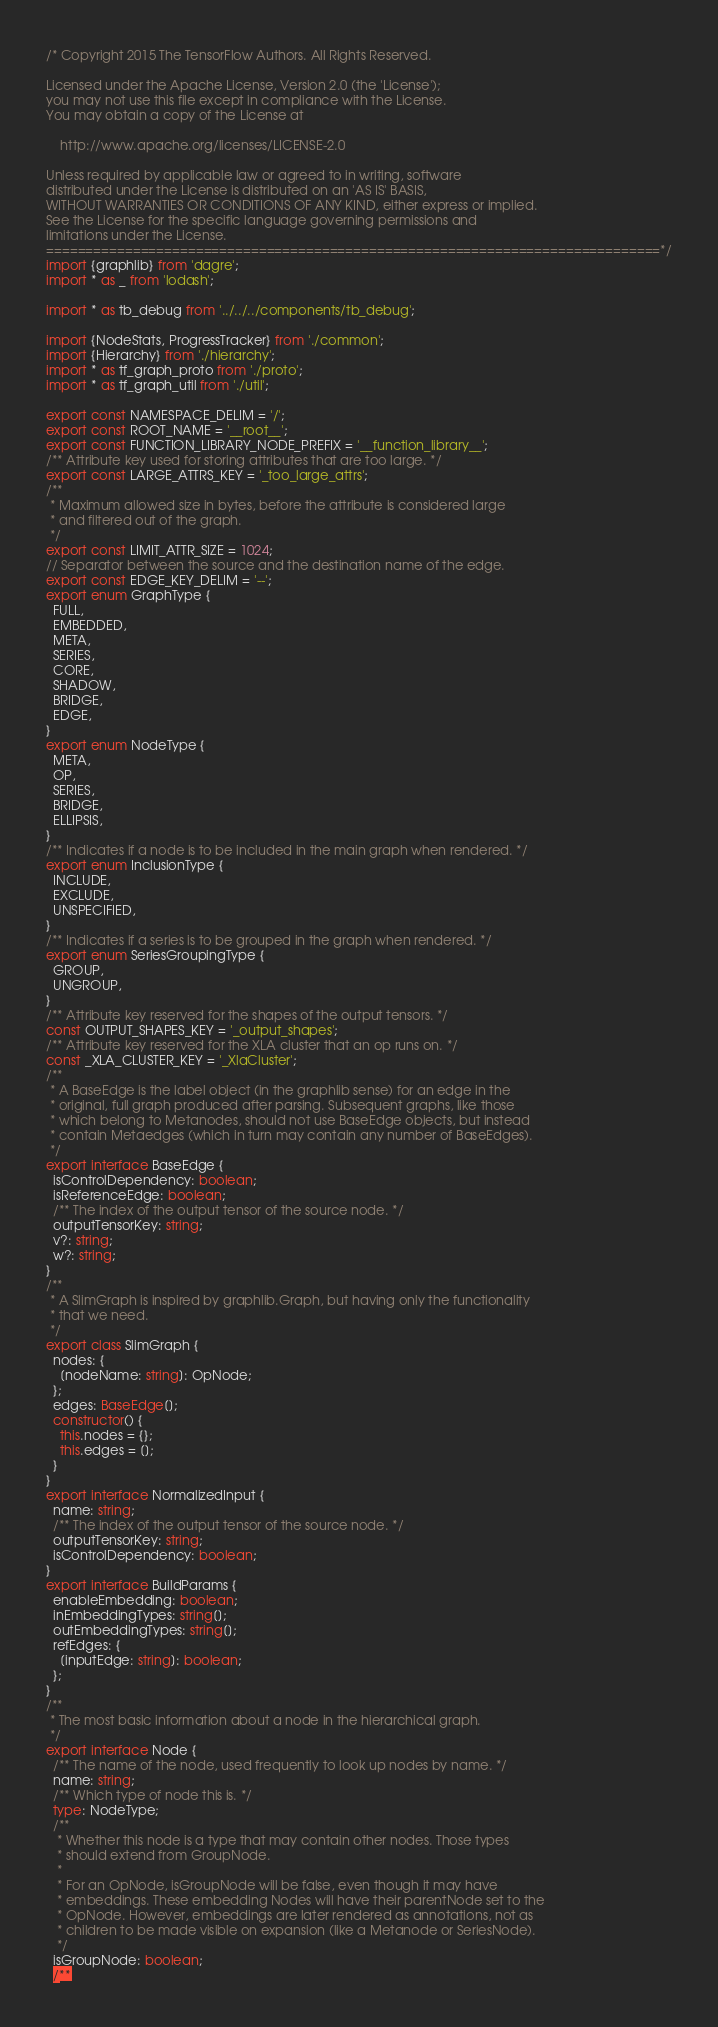Convert code to text. <code><loc_0><loc_0><loc_500><loc_500><_TypeScript_>/* Copyright 2015 The TensorFlow Authors. All Rights Reserved.

Licensed under the Apache License, Version 2.0 (the 'License');
you may not use this file except in compliance with the License.
You may obtain a copy of the License at

    http://www.apache.org/licenses/LICENSE-2.0

Unless required by applicable law or agreed to in writing, software
distributed under the License is distributed on an 'AS IS' BASIS,
WITHOUT WARRANTIES OR CONDITIONS OF ANY KIND, either express or implied.
See the License for the specific language governing permissions and
limitations under the License.
==============================================================================*/
import {graphlib} from 'dagre';
import * as _ from 'lodash';

import * as tb_debug from '../../../components/tb_debug';

import {NodeStats, ProgressTracker} from './common';
import {Hierarchy} from './hierarchy';
import * as tf_graph_proto from './proto';
import * as tf_graph_util from './util';

export const NAMESPACE_DELIM = '/';
export const ROOT_NAME = '__root__';
export const FUNCTION_LIBRARY_NODE_PREFIX = '__function_library__';
/** Attribute key used for storing attributes that are too large. */
export const LARGE_ATTRS_KEY = '_too_large_attrs';
/**
 * Maximum allowed size in bytes, before the attribute is considered large
 * and filtered out of the graph.
 */
export const LIMIT_ATTR_SIZE = 1024;
// Separator between the source and the destination name of the edge.
export const EDGE_KEY_DELIM = '--';
export enum GraphType {
  FULL,
  EMBEDDED,
  META,
  SERIES,
  CORE,
  SHADOW,
  BRIDGE,
  EDGE,
}
export enum NodeType {
  META,
  OP,
  SERIES,
  BRIDGE,
  ELLIPSIS,
}
/** Indicates if a node is to be included in the main graph when rendered. */
export enum InclusionType {
  INCLUDE,
  EXCLUDE,
  UNSPECIFIED,
}
/** Indicates if a series is to be grouped in the graph when rendered. */
export enum SeriesGroupingType {
  GROUP,
  UNGROUP,
}
/** Attribute key reserved for the shapes of the output tensors. */
const OUTPUT_SHAPES_KEY = '_output_shapes';
/** Attribute key reserved for the XLA cluster that an op runs on. */
const _XLA_CLUSTER_KEY = '_XlaCluster';
/**
 * A BaseEdge is the label object (in the graphlib sense) for an edge in the
 * original, full graph produced after parsing. Subsequent graphs, like those
 * which belong to Metanodes, should not use BaseEdge objects, but instead
 * contain Metaedges (which in turn may contain any number of BaseEdges).
 */
export interface BaseEdge {
  isControlDependency: boolean;
  isReferenceEdge: boolean;
  /** The index of the output tensor of the source node. */
  outputTensorKey: string;
  v?: string;
  w?: string;
}
/**
 * A SlimGraph is inspired by graphlib.Graph, but having only the functionality
 * that we need.
 */
export class SlimGraph {
  nodes: {
    [nodeName: string]: OpNode;
  };
  edges: BaseEdge[];
  constructor() {
    this.nodes = {};
    this.edges = [];
  }
}
export interface NormalizedInput {
  name: string;
  /** The index of the output tensor of the source node. */
  outputTensorKey: string;
  isControlDependency: boolean;
}
export interface BuildParams {
  enableEmbedding: boolean;
  inEmbeddingTypes: string[];
  outEmbeddingTypes: string[];
  refEdges: {
    [inputEdge: string]: boolean;
  };
}
/**
 * The most basic information about a node in the hierarchical graph.
 */
export interface Node {
  /** The name of the node, used frequently to look up nodes by name. */
  name: string;
  /** Which type of node this is. */
  type: NodeType;
  /**
   * Whether this node is a type that may contain other nodes. Those types
   * should extend from GroupNode.
   *
   * For an OpNode, isGroupNode will be false, even though it may have
   * embeddings. These embedding Nodes will have their parentNode set to the
   * OpNode. However, embeddings are later rendered as annotations, not as
   * children to be made visible on expansion (like a Metanode or SeriesNode).
   */
  isGroupNode: boolean;
  /**</code> 